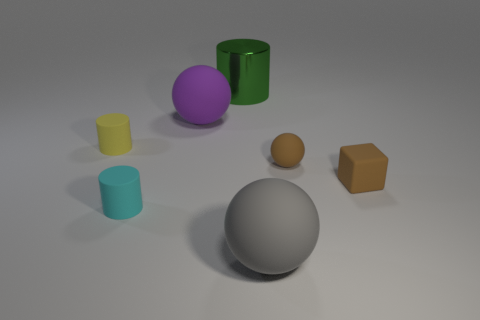Are there any other things that are the same color as the metallic cylinder?
Give a very brief answer. No. Is the gray rubber thing the same shape as the purple rubber thing?
Ensure brevity in your answer.  Yes. What is the size of the matte sphere that is left of the cylinder that is to the right of the small cylinder that is in front of the yellow rubber thing?
Keep it short and to the point. Large. How many other things are the same material as the cyan cylinder?
Keep it short and to the point. 5. There is a tiny cylinder behind the block; what color is it?
Your answer should be compact. Yellow. What is the cylinder that is on the right side of the tiny matte cylinder that is in front of the cylinder left of the cyan rubber cylinder made of?
Give a very brief answer. Metal. Are there any other large rubber objects that have the same shape as the yellow object?
Offer a terse response. No. The yellow thing that is the same size as the cyan matte cylinder is what shape?
Offer a terse response. Cylinder. What number of tiny things are both in front of the small brown rubber sphere and on the left side of the big shiny object?
Offer a terse response. 1. Is the number of gray objects that are on the left side of the tiny yellow matte cylinder less than the number of green cylinders?
Provide a succinct answer. Yes. 